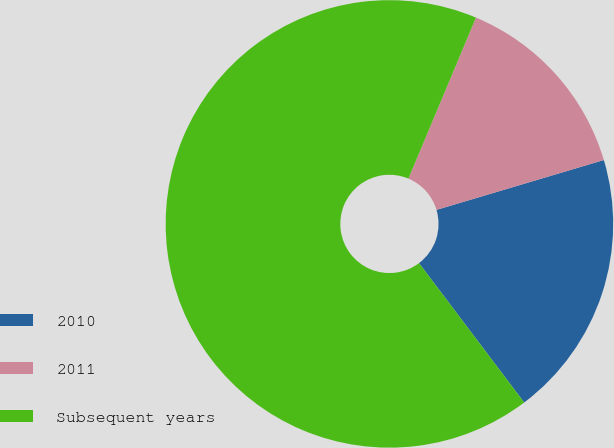Convert chart to OTSL. <chart><loc_0><loc_0><loc_500><loc_500><pie_chart><fcel>2010<fcel>2011<fcel>Subsequent years<nl><fcel>19.32%<fcel>14.07%<fcel>66.61%<nl></chart> 